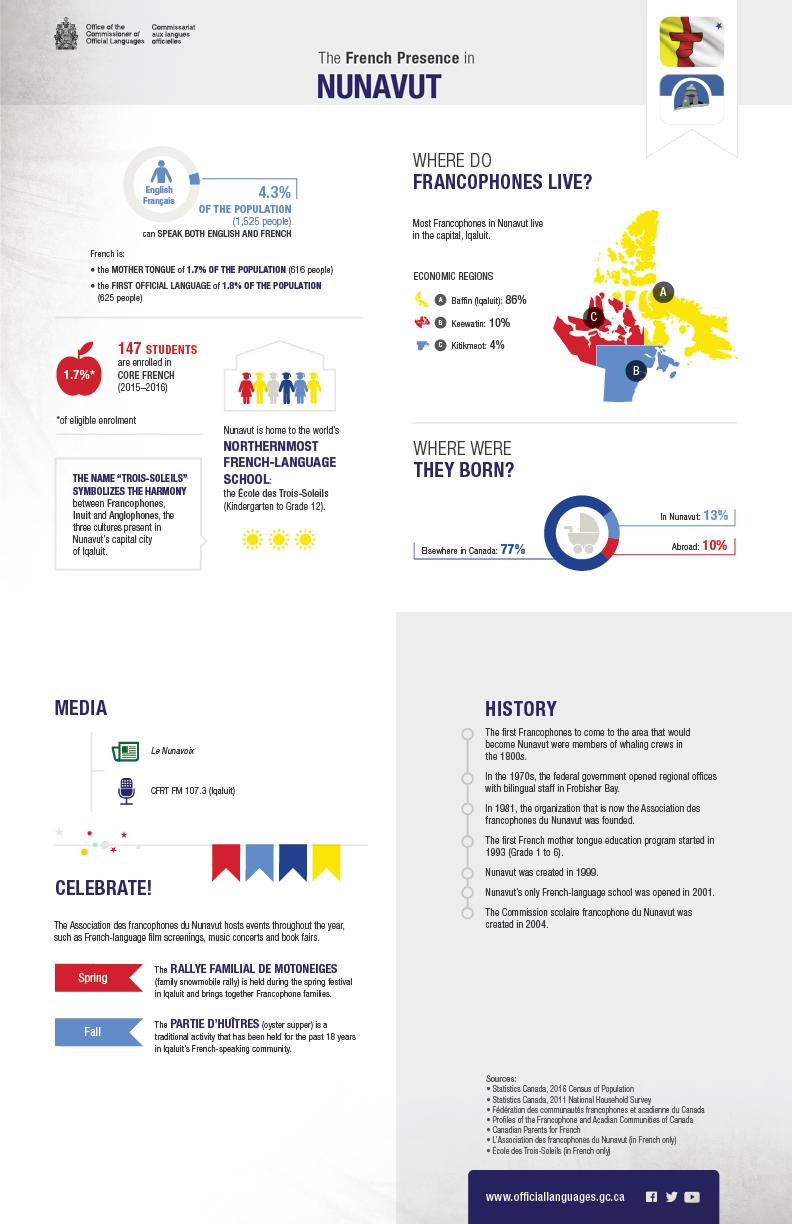Give some essential details in this illustration. This infographic mentions 3 economic regions. 